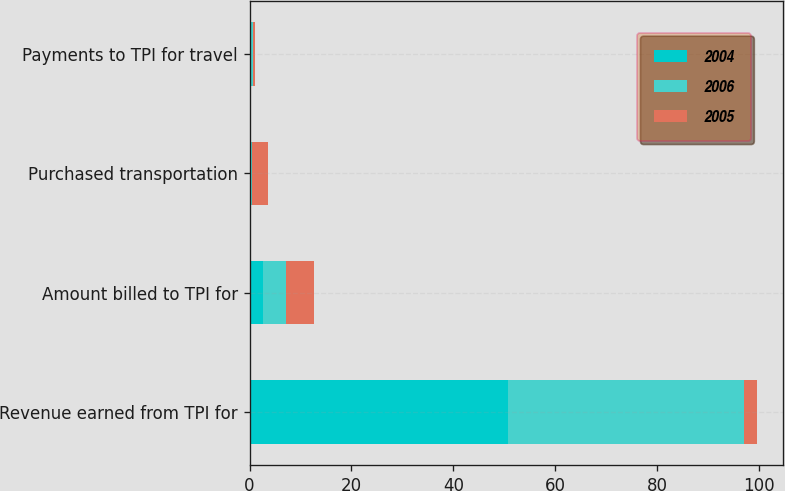Convert chart. <chart><loc_0><loc_0><loc_500><loc_500><stacked_bar_chart><ecel><fcel>Revenue earned from TPI for<fcel>Amount billed to TPI for<fcel>Purchased transportation<fcel>Payments to TPI for travel<nl><fcel>2004<fcel>50.8<fcel>2.6<fcel>0.2<fcel>0.3<nl><fcel>2006<fcel>46.2<fcel>4.6<fcel>0.2<fcel>0.4<nl><fcel>2005<fcel>2.6<fcel>5.4<fcel>3.3<fcel>0.4<nl></chart> 